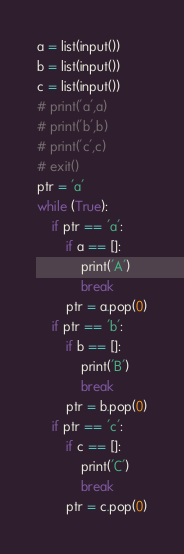<code> <loc_0><loc_0><loc_500><loc_500><_Python_>a = list(input())
b = list(input())
c = list(input())
# print('a',a)
# print('b',b)
# print('c',c)
# exit()
ptr = 'a'
while (True):
	if ptr == 'a':
		if a == []:
			print('A')
			break
		ptr = a.pop(0)
	if ptr == 'b':
		if b == []:
			print('B')
			break
		ptr = b.pop(0)
	if ptr == 'c':
		if c == []:
			print('C')
			break
		ptr = c.pop(0)
</code> 